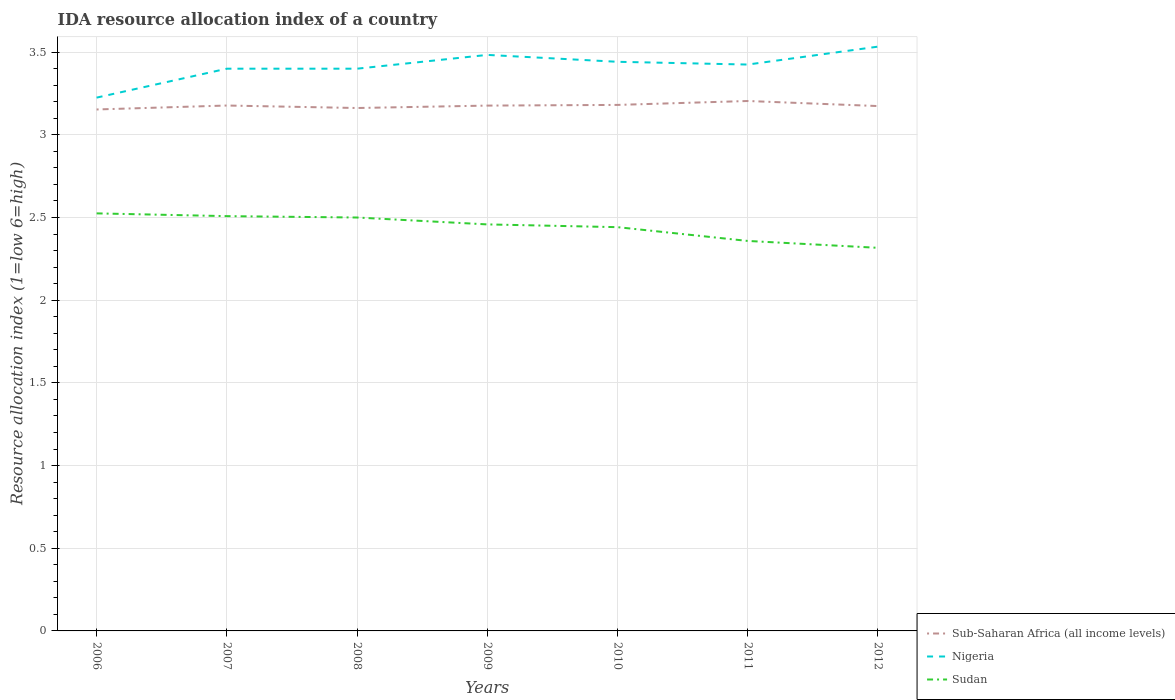Across all years, what is the maximum IDA resource allocation index in Nigeria?
Provide a succinct answer. 3.23. What is the total IDA resource allocation index in Nigeria in the graph?
Ensure brevity in your answer.  -0.09. What is the difference between the highest and the second highest IDA resource allocation index in Sub-Saharan Africa (all income levels)?
Give a very brief answer. 0.05. Is the IDA resource allocation index in Nigeria strictly greater than the IDA resource allocation index in Sudan over the years?
Your answer should be very brief. No. How many years are there in the graph?
Give a very brief answer. 7. Are the values on the major ticks of Y-axis written in scientific E-notation?
Ensure brevity in your answer.  No. Does the graph contain grids?
Make the answer very short. Yes. How many legend labels are there?
Make the answer very short. 3. How are the legend labels stacked?
Offer a terse response. Vertical. What is the title of the graph?
Your response must be concise. IDA resource allocation index of a country. Does "Sub-Saharan Africa (developing only)" appear as one of the legend labels in the graph?
Provide a short and direct response. No. What is the label or title of the Y-axis?
Keep it short and to the point. Resource allocation index (1=low 6=high). What is the Resource allocation index (1=low 6=high) in Sub-Saharan Africa (all income levels) in 2006?
Your answer should be very brief. 3.15. What is the Resource allocation index (1=low 6=high) in Nigeria in 2006?
Keep it short and to the point. 3.23. What is the Resource allocation index (1=low 6=high) of Sudan in 2006?
Give a very brief answer. 2.52. What is the Resource allocation index (1=low 6=high) of Sub-Saharan Africa (all income levels) in 2007?
Ensure brevity in your answer.  3.18. What is the Resource allocation index (1=low 6=high) of Sudan in 2007?
Offer a terse response. 2.51. What is the Resource allocation index (1=low 6=high) of Sub-Saharan Africa (all income levels) in 2008?
Make the answer very short. 3.16. What is the Resource allocation index (1=low 6=high) in Sub-Saharan Africa (all income levels) in 2009?
Your answer should be very brief. 3.18. What is the Resource allocation index (1=low 6=high) of Nigeria in 2009?
Provide a short and direct response. 3.48. What is the Resource allocation index (1=low 6=high) in Sudan in 2009?
Ensure brevity in your answer.  2.46. What is the Resource allocation index (1=low 6=high) in Sub-Saharan Africa (all income levels) in 2010?
Your answer should be very brief. 3.18. What is the Resource allocation index (1=low 6=high) in Nigeria in 2010?
Give a very brief answer. 3.44. What is the Resource allocation index (1=low 6=high) in Sudan in 2010?
Offer a terse response. 2.44. What is the Resource allocation index (1=low 6=high) of Sub-Saharan Africa (all income levels) in 2011?
Give a very brief answer. 3.2. What is the Resource allocation index (1=low 6=high) of Nigeria in 2011?
Provide a succinct answer. 3.42. What is the Resource allocation index (1=low 6=high) of Sudan in 2011?
Offer a very short reply. 2.36. What is the Resource allocation index (1=low 6=high) of Sub-Saharan Africa (all income levels) in 2012?
Offer a terse response. 3.17. What is the Resource allocation index (1=low 6=high) in Nigeria in 2012?
Make the answer very short. 3.53. What is the Resource allocation index (1=low 6=high) of Sudan in 2012?
Your response must be concise. 2.32. Across all years, what is the maximum Resource allocation index (1=low 6=high) of Sub-Saharan Africa (all income levels)?
Give a very brief answer. 3.2. Across all years, what is the maximum Resource allocation index (1=low 6=high) in Nigeria?
Give a very brief answer. 3.53. Across all years, what is the maximum Resource allocation index (1=low 6=high) in Sudan?
Keep it short and to the point. 2.52. Across all years, what is the minimum Resource allocation index (1=low 6=high) in Sub-Saharan Africa (all income levels)?
Give a very brief answer. 3.15. Across all years, what is the minimum Resource allocation index (1=low 6=high) of Nigeria?
Give a very brief answer. 3.23. Across all years, what is the minimum Resource allocation index (1=low 6=high) of Sudan?
Your answer should be very brief. 2.32. What is the total Resource allocation index (1=low 6=high) of Sub-Saharan Africa (all income levels) in the graph?
Your response must be concise. 22.23. What is the total Resource allocation index (1=low 6=high) in Nigeria in the graph?
Provide a succinct answer. 23.91. What is the total Resource allocation index (1=low 6=high) of Sudan in the graph?
Your answer should be very brief. 17.11. What is the difference between the Resource allocation index (1=low 6=high) in Sub-Saharan Africa (all income levels) in 2006 and that in 2007?
Provide a succinct answer. -0.02. What is the difference between the Resource allocation index (1=low 6=high) of Nigeria in 2006 and that in 2007?
Provide a succinct answer. -0.17. What is the difference between the Resource allocation index (1=low 6=high) in Sudan in 2006 and that in 2007?
Your answer should be compact. 0.02. What is the difference between the Resource allocation index (1=low 6=high) of Sub-Saharan Africa (all income levels) in 2006 and that in 2008?
Your answer should be compact. -0.01. What is the difference between the Resource allocation index (1=low 6=high) of Nigeria in 2006 and that in 2008?
Keep it short and to the point. -0.17. What is the difference between the Resource allocation index (1=low 6=high) of Sudan in 2006 and that in 2008?
Give a very brief answer. 0.03. What is the difference between the Resource allocation index (1=low 6=high) of Sub-Saharan Africa (all income levels) in 2006 and that in 2009?
Provide a succinct answer. -0.02. What is the difference between the Resource allocation index (1=low 6=high) of Nigeria in 2006 and that in 2009?
Make the answer very short. -0.26. What is the difference between the Resource allocation index (1=low 6=high) in Sudan in 2006 and that in 2009?
Your response must be concise. 0.07. What is the difference between the Resource allocation index (1=low 6=high) of Sub-Saharan Africa (all income levels) in 2006 and that in 2010?
Provide a short and direct response. -0.03. What is the difference between the Resource allocation index (1=low 6=high) in Nigeria in 2006 and that in 2010?
Offer a very short reply. -0.22. What is the difference between the Resource allocation index (1=low 6=high) of Sudan in 2006 and that in 2010?
Offer a very short reply. 0.08. What is the difference between the Resource allocation index (1=low 6=high) of Sub-Saharan Africa (all income levels) in 2006 and that in 2011?
Make the answer very short. -0.05. What is the difference between the Resource allocation index (1=low 6=high) in Nigeria in 2006 and that in 2011?
Your answer should be very brief. -0.2. What is the difference between the Resource allocation index (1=low 6=high) in Sudan in 2006 and that in 2011?
Your response must be concise. 0.17. What is the difference between the Resource allocation index (1=low 6=high) of Sub-Saharan Africa (all income levels) in 2006 and that in 2012?
Ensure brevity in your answer.  -0.02. What is the difference between the Resource allocation index (1=low 6=high) of Nigeria in 2006 and that in 2012?
Provide a succinct answer. -0.31. What is the difference between the Resource allocation index (1=low 6=high) in Sudan in 2006 and that in 2012?
Ensure brevity in your answer.  0.21. What is the difference between the Resource allocation index (1=low 6=high) of Sub-Saharan Africa (all income levels) in 2007 and that in 2008?
Provide a succinct answer. 0.02. What is the difference between the Resource allocation index (1=low 6=high) of Nigeria in 2007 and that in 2008?
Offer a very short reply. 0. What is the difference between the Resource allocation index (1=low 6=high) in Sudan in 2007 and that in 2008?
Keep it short and to the point. 0.01. What is the difference between the Resource allocation index (1=low 6=high) of Nigeria in 2007 and that in 2009?
Provide a short and direct response. -0.08. What is the difference between the Resource allocation index (1=low 6=high) in Sub-Saharan Africa (all income levels) in 2007 and that in 2010?
Offer a very short reply. -0. What is the difference between the Resource allocation index (1=low 6=high) in Nigeria in 2007 and that in 2010?
Your answer should be compact. -0.04. What is the difference between the Resource allocation index (1=low 6=high) of Sudan in 2007 and that in 2010?
Offer a very short reply. 0.07. What is the difference between the Resource allocation index (1=low 6=high) in Sub-Saharan Africa (all income levels) in 2007 and that in 2011?
Your answer should be very brief. -0.03. What is the difference between the Resource allocation index (1=low 6=high) in Nigeria in 2007 and that in 2011?
Your answer should be very brief. -0.03. What is the difference between the Resource allocation index (1=low 6=high) of Sub-Saharan Africa (all income levels) in 2007 and that in 2012?
Your response must be concise. 0. What is the difference between the Resource allocation index (1=low 6=high) in Nigeria in 2007 and that in 2012?
Offer a very short reply. -0.13. What is the difference between the Resource allocation index (1=low 6=high) in Sudan in 2007 and that in 2012?
Provide a succinct answer. 0.19. What is the difference between the Resource allocation index (1=low 6=high) in Sub-Saharan Africa (all income levels) in 2008 and that in 2009?
Offer a very short reply. -0.01. What is the difference between the Resource allocation index (1=low 6=high) in Nigeria in 2008 and that in 2009?
Offer a very short reply. -0.08. What is the difference between the Resource allocation index (1=low 6=high) in Sudan in 2008 and that in 2009?
Offer a terse response. 0.04. What is the difference between the Resource allocation index (1=low 6=high) in Sub-Saharan Africa (all income levels) in 2008 and that in 2010?
Your response must be concise. -0.02. What is the difference between the Resource allocation index (1=low 6=high) in Nigeria in 2008 and that in 2010?
Your answer should be very brief. -0.04. What is the difference between the Resource allocation index (1=low 6=high) in Sudan in 2008 and that in 2010?
Offer a very short reply. 0.06. What is the difference between the Resource allocation index (1=low 6=high) of Sub-Saharan Africa (all income levels) in 2008 and that in 2011?
Keep it short and to the point. -0.04. What is the difference between the Resource allocation index (1=low 6=high) of Nigeria in 2008 and that in 2011?
Your response must be concise. -0.03. What is the difference between the Resource allocation index (1=low 6=high) in Sudan in 2008 and that in 2011?
Make the answer very short. 0.14. What is the difference between the Resource allocation index (1=low 6=high) in Sub-Saharan Africa (all income levels) in 2008 and that in 2012?
Your answer should be compact. -0.01. What is the difference between the Resource allocation index (1=low 6=high) in Nigeria in 2008 and that in 2012?
Your response must be concise. -0.13. What is the difference between the Resource allocation index (1=low 6=high) in Sudan in 2008 and that in 2012?
Your answer should be compact. 0.18. What is the difference between the Resource allocation index (1=low 6=high) of Sub-Saharan Africa (all income levels) in 2009 and that in 2010?
Provide a short and direct response. -0. What is the difference between the Resource allocation index (1=low 6=high) in Nigeria in 2009 and that in 2010?
Offer a terse response. 0.04. What is the difference between the Resource allocation index (1=low 6=high) of Sudan in 2009 and that in 2010?
Make the answer very short. 0.02. What is the difference between the Resource allocation index (1=low 6=high) of Sub-Saharan Africa (all income levels) in 2009 and that in 2011?
Provide a short and direct response. -0.03. What is the difference between the Resource allocation index (1=low 6=high) of Nigeria in 2009 and that in 2011?
Your answer should be compact. 0.06. What is the difference between the Resource allocation index (1=low 6=high) of Sub-Saharan Africa (all income levels) in 2009 and that in 2012?
Ensure brevity in your answer.  0. What is the difference between the Resource allocation index (1=low 6=high) of Sudan in 2009 and that in 2012?
Provide a short and direct response. 0.14. What is the difference between the Resource allocation index (1=low 6=high) of Sub-Saharan Africa (all income levels) in 2010 and that in 2011?
Give a very brief answer. -0.02. What is the difference between the Resource allocation index (1=low 6=high) in Nigeria in 2010 and that in 2011?
Offer a very short reply. 0.02. What is the difference between the Resource allocation index (1=low 6=high) of Sudan in 2010 and that in 2011?
Offer a terse response. 0.08. What is the difference between the Resource allocation index (1=low 6=high) of Sub-Saharan Africa (all income levels) in 2010 and that in 2012?
Provide a succinct answer. 0.01. What is the difference between the Resource allocation index (1=low 6=high) in Nigeria in 2010 and that in 2012?
Offer a terse response. -0.09. What is the difference between the Resource allocation index (1=low 6=high) of Sub-Saharan Africa (all income levels) in 2011 and that in 2012?
Keep it short and to the point. 0.03. What is the difference between the Resource allocation index (1=low 6=high) of Nigeria in 2011 and that in 2012?
Offer a terse response. -0.11. What is the difference between the Resource allocation index (1=low 6=high) in Sudan in 2011 and that in 2012?
Your answer should be compact. 0.04. What is the difference between the Resource allocation index (1=low 6=high) in Sub-Saharan Africa (all income levels) in 2006 and the Resource allocation index (1=low 6=high) in Nigeria in 2007?
Provide a succinct answer. -0.25. What is the difference between the Resource allocation index (1=low 6=high) of Sub-Saharan Africa (all income levels) in 2006 and the Resource allocation index (1=low 6=high) of Sudan in 2007?
Your answer should be very brief. 0.65. What is the difference between the Resource allocation index (1=low 6=high) in Nigeria in 2006 and the Resource allocation index (1=low 6=high) in Sudan in 2007?
Provide a succinct answer. 0.72. What is the difference between the Resource allocation index (1=low 6=high) of Sub-Saharan Africa (all income levels) in 2006 and the Resource allocation index (1=low 6=high) of Nigeria in 2008?
Provide a short and direct response. -0.25. What is the difference between the Resource allocation index (1=low 6=high) of Sub-Saharan Africa (all income levels) in 2006 and the Resource allocation index (1=low 6=high) of Sudan in 2008?
Offer a very short reply. 0.65. What is the difference between the Resource allocation index (1=low 6=high) in Nigeria in 2006 and the Resource allocation index (1=low 6=high) in Sudan in 2008?
Your answer should be very brief. 0.72. What is the difference between the Resource allocation index (1=low 6=high) in Sub-Saharan Africa (all income levels) in 2006 and the Resource allocation index (1=low 6=high) in Nigeria in 2009?
Your answer should be compact. -0.33. What is the difference between the Resource allocation index (1=low 6=high) in Sub-Saharan Africa (all income levels) in 2006 and the Resource allocation index (1=low 6=high) in Sudan in 2009?
Your answer should be compact. 0.69. What is the difference between the Resource allocation index (1=low 6=high) of Nigeria in 2006 and the Resource allocation index (1=low 6=high) of Sudan in 2009?
Ensure brevity in your answer.  0.77. What is the difference between the Resource allocation index (1=low 6=high) of Sub-Saharan Africa (all income levels) in 2006 and the Resource allocation index (1=low 6=high) of Nigeria in 2010?
Offer a very short reply. -0.29. What is the difference between the Resource allocation index (1=low 6=high) of Sub-Saharan Africa (all income levels) in 2006 and the Resource allocation index (1=low 6=high) of Sudan in 2010?
Ensure brevity in your answer.  0.71. What is the difference between the Resource allocation index (1=low 6=high) in Nigeria in 2006 and the Resource allocation index (1=low 6=high) in Sudan in 2010?
Make the answer very short. 0.78. What is the difference between the Resource allocation index (1=low 6=high) in Sub-Saharan Africa (all income levels) in 2006 and the Resource allocation index (1=low 6=high) in Nigeria in 2011?
Ensure brevity in your answer.  -0.27. What is the difference between the Resource allocation index (1=low 6=high) in Sub-Saharan Africa (all income levels) in 2006 and the Resource allocation index (1=low 6=high) in Sudan in 2011?
Make the answer very short. 0.8. What is the difference between the Resource allocation index (1=low 6=high) in Nigeria in 2006 and the Resource allocation index (1=low 6=high) in Sudan in 2011?
Offer a very short reply. 0.87. What is the difference between the Resource allocation index (1=low 6=high) in Sub-Saharan Africa (all income levels) in 2006 and the Resource allocation index (1=low 6=high) in Nigeria in 2012?
Ensure brevity in your answer.  -0.38. What is the difference between the Resource allocation index (1=low 6=high) of Sub-Saharan Africa (all income levels) in 2006 and the Resource allocation index (1=low 6=high) of Sudan in 2012?
Provide a succinct answer. 0.84. What is the difference between the Resource allocation index (1=low 6=high) in Nigeria in 2006 and the Resource allocation index (1=low 6=high) in Sudan in 2012?
Ensure brevity in your answer.  0.91. What is the difference between the Resource allocation index (1=low 6=high) of Sub-Saharan Africa (all income levels) in 2007 and the Resource allocation index (1=low 6=high) of Nigeria in 2008?
Provide a short and direct response. -0.22. What is the difference between the Resource allocation index (1=low 6=high) in Sub-Saharan Africa (all income levels) in 2007 and the Resource allocation index (1=low 6=high) in Sudan in 2008?
Make the answer very short. 0.68. What is the difference between the Resource allocation index (1=low 6=high) in Sub-Saharan Africa (all income levels) in 2007 and the Resource allocation index (1=low 6=high) in Nigeria in 2009?
Make the answer very short. -0.31. What is the difference between the Resource allocation index (1=low 6=high) in Sub-Saharan Africa (all income levels) in 2007 and the Resource allocation index (1=low 6=high) in Sudan in 2009?
Provide a succinct answer. 0.72. What is the difference between the Resource allocation index (1=low 6=high) of Nigeria in 2007 and the Resource allocation index (1=low 6=high) of Sudan in 2009?
Your answer should be very brief. 0.94. What is the difference between the Resource allocation index (1=low 6=high) in Sub-Saharan Africa (all income levels) in 2007 and the Resource allocation index (1=low 6=high) in Nigeria in 2010?
Keep it short and to the point. -0.26. What is the difference between the Resource allocation index (1=low 6=high) of Sub-Saharan Africa (all income levels) in 2007 and the Resource allocation index (1=low 6=high) of Sudan in 2010?
Your response must be concise. 0.74. What is the difference between the Resource allocation index (1=low 6=high) of Nigeria in 2007 and the Resource allocation index (1=low 6=high) of Sudan in 2010?
Ensure brevity in your answer.  0.96. What is the difference between the Resource allocation index (1=low 6=high) in Sub-Saharan Africa (all income levels) in 2007 and the Resource allocation index (1=low 6=high) in Nigeria in 2011?
Your answer should be very brief. -0.25. What is the difference between the Resource allocation index (1=low 6=high) in Sub-Saharan Africa (all income levels) in 2007 and the Resource allocation index (1=low 6=high) in Sudan in 2011?
Your answer should be very brief. 0.82. What is the difference between the Resource allocation index (1=low 6=high) in Nigeria in 2007 and the Resource allocation index (1=low 6=high) in Sudan in 2011?
Your answer should be very brief. 1.04. What is the difference between the Resource allocation index (1=low 6=high) in Sub-Saharan Africa (all income levels) in 2007 and the Resource allocation index (1=low 6=high) in Nigeria in 2012?
Ensure brevity in your answer.  -0.36. What is the difference between the Resource allocation index (1=low 6=high) in Sub-Saharan Africa (all income levels) in 2007 and the Resource allocation index (1=low 6=high) in Sudan in 2012?
Make the answer very short. 0.86. What is the difference between the Resource allocation index (1=low 6=high) of Sub-Saharan Africa (all income levels) in 2008 and the Resource allocation index (1=low 6=high) of Nigeria in 2009?
Keep it short and to the point. -0.32. What is the difference between the Resource allocation index (1=low 6=high) of Sub-Saharan Africa (all income levels) in 2008 and the Resource allocation index (1=low 6=high) of Sudan in 2009?
Provide a short and direct response. 0.7. What is the difference between the Resource allocation index (1=low 6=high) of Nigeria in 2008 and the Resource allocation index (1=low 6=high) of Sudan in 2009?
Give a very brief answer. 0.94. What is the difference between the Resource allocation index (1=low 6=high) in Sub-Saharan Africa (all income levels) in 2008 and the Resource allocation index (1=low 6=high) in Nigeria in 2010?
Make the answer very short. -0.28. What is the difference between the Resource allocation index (1=low 6=high) of Sub-Saharan Africa (all income levels) in 2008 and the Resource allocation index (1=low 6=high) of Sudan in 2010?
Your answer should be very brief. 0.72. What is the difference between the Resource allocation index (1=low 6=high) in Sub-Saharan Africa (all income levels) in 2008 and the Resource allocation index (1=low 6=high) in Nigeria in 2011?
Keep it short and to the point. -0.26. What is the difference between the Resource allocation index (1=low 6=high) in Sub-Saharan Africa (all income levels) in 2008 and the Resource allocation index (1=low 6=high) in Sudan in 2011?
Ensure brevity in your answer.  0.8. What is the difference between the Resource allocation index (1=low 6=high) in Nigeria in 2008 and the Resource allocation index (1=low 6=high) in Sudan in 2011?
Your answer should be very brief. 1.04. What is the difference between the Resource allocation index (1=low 6=high) of Sub-Saharan Africa (all income levels) in 2008 and the Resource allocation index (1=low 6=high) of Nigeria in 2012?
Make the answer very short. -0.37. What is the difference between the Resource allocation index (1=low 6=high) in Sub-Saharan Africa (all income levels) in 2008 and the Resource allocation index (1=low 6=high) in Sudan in 2012?
Offer a very short reply. 0.85. What is the difference between the Resource allocation index (1=low 6=high) of Nigeria in 2008 and the Resource allocation index (1=low 6=high) of Sudan in 2012?
Offer a very short reply. 1.08. What is the difference between the Resource allocation index (1=low 6=high) of Sub-Saharan Africa (all income levels) in 2009 and the Resource allocation index (1=low 6=high) of Nigeria in 2010?
Ensure brevity in your answer.  -0.26. What is the difference between the Resource allocation index (1=low 6=high) in Sub-Saharan Africa (all income levels) in 2009 and the Resource allocation index (1=low 6=high) in Sudan in 2010?
Make the answer very short. 0.74. What is the difference between the Resource allocation index (1=low 6=high) in Nigeria in 2009 and the Resource allocation index (1=low 6=high) in Sudan in 2010?
Your answer should be compact. 1.04. What is the difference between the Resource allocation index (1=low 6=high) of Sub-Saharan Africa (all income levels) in 2009 and the Resource allocation index (1=low 6=high) of Nigeria in 2011?
Keep it short and to the point. -0.25. What is the difference between the Resource allocation index (1=low 6=high) in Sub-Saharan Africa (all income levels) in 2009 and the Resource allocation index (1=low 6=high) in Sudan in 2011?
Provide a short and direct response. 0.82. What is the difference between the Resource allocation index (1=low 6=high) in Nigeria in 2009 and the Resource allocation index (1=low 6=high) in Sudan in 2011?
Your response must be concise. 1.12. What is the difference between the Resource allocation index (1=low 6=high) of Sub-Saharan Africa (all income levels) in 2009 and the Resource allocation index (1=low 6=high) of Nigeria in 2012?
Offer a very short reply. -0.36. What is the difference between the Resource allocation index (1=low 6=high) of Sub-Saharan Africa (all income levels) in 2009 and the Resource allocation index (1=low 6=high) of Sudan in 2012?
Provide a short and direct response. 0.86. What is the difference between the Resource allocation index (1=low 6=high) in Nigeria in 2009 and the Resource allocation index (1=low 6=high) in Sudan in 2012?
Make the answer very short. 1.17. What is the difference between the Resource allocation index (1=low 6=high) in Sub-Saharan Africa (all income levels) in 2010 and the Resource allocation index (1=low 6=high) in Nigeria in 2011?
Keep it short and to the point. -0.24. What is the difference between the Resource allocation index (1=low 6=high) of Sub-Saharan Africa (all income levels) in 2010 and the Resource allocation index (1=low 6=high) of Sudan in 2011?
Keep it short and to the point. 0.82. What is the difference between the Resource allocation index (1=low 6=high) in Sub-Saharan Africa (all income levels) in 2010 and the Resource allocation index (1=low 6=high) in Nigeria in 2012?
Give a very brief answer. -0.35. What is the difference between the Resource allocation index (1=low 6=high) of Sub-Saharan Africa (all income levels) in 2010 and the Resource allocation index (1=low 6=high) of Sudan in 2012?
Your answer should be compact. 0.86. What is the difference between the Resource allocation index (1=low 6=high) of Nigeria in 2010 and the Resource allocation index (1=low 6=high) of Sudan in 2012?
Offer a very short reply. 1.12. What is the difference between the Resource allocation index (1=low 6=high) of Sub-Saharan Africa (all income levels) in 2011 and the Resource allocation index (1=low 6=high) of Nigeria in 2012?
Keep it short and to the point. -0.33. What is the difference between the Resource allocation index (1=low 6=high) of Sub-Saharan Africa (all income levels) in 2011 and the Resource allocation index (1=low 6=high) of Sudan in 2012?
Offer a very short reply. 0.89. What is the difference between the Resource allocation index (1=low 6=high) in Nigeria in 2011 and the Resource allocation index (1=low 6=high) in Sudan in 2012?
Provide a short and direct response. 1.11. What is the average Resource allocation index (1=low 6=high) of Sub-Saharan Africa (all income levels) per year?
Offer a very short reply. 3.18. What is the average Resource allocation index (1=low 6=high) of Nigeria per year?
Your answer should be compact. 3.42. What is the average Resource allocation index (1=low 6=high) in Sudan per year?
Ensure brevity in your answer.  2.44. In the year 2006, what is the difference between the Resource allocation index (1=low 6=high) in Sub-Saharan Africa (all income levels) and Resource allocation index (1=low 6=high) in Nigeria?
Your answer should be compact. -0.07. In the year 2006, what is the difference between the Resource allocation index (1=low 6=high) in Sub-Saharan Africa (all income levels) and Resource allocation index (1=low 6=high) in Sudan?
Offer a terse response. 0.63. In the year 2006, what is the difference between the Resource allocation index (1=low 6=high) in Nigeria and Resource allocation index (1=low 6=high) in Sudan?
Ensure brevity in your answer.  0.7. In the year 2007, what is the difference between the Resource allocation index (1=low 6=high) in Sub-Saharan Africa (all income levels) and Resource allocation index (1=low 6=high) in Nigeria?
Give a very brief answer. -0.22. In the year 2007, what is the difference between the Resource allocation index (1=low 6=high) of Sub-Saharan Africa (all income levels) and Resource allocation index (1=low 6=high) of Sudan?
Offer a terse response. 0.67. In the year 2007, what is the difference between the Resource allocation index (1=low 6=high) of Nigeria and Resource allocation index (1=low 6=high) of Sudan?
Offer a very short reply. 0.89. In the year 2008, what is the difference between the Resource allocation index (1=low 6=high) of Sub-Saharan Africa (all income levels) and Resource allocation index (1=low 6=high) of Nigeria?
Keep it short and to the point. -0.24. In the year 2008, what is the difference between the Resource allocation index (1=low 6=high) of Sub-Saharan Africa (all income levels) and Resource allocation index (1=low 6=high) of Sudan?
Provide a succinct answer. 0.66. In the year 2009, what is the difference between the Resource allocation index (1=low 6=high) of Sub-Saharan Africa (all income levels) and Resource allocation index (1=low 6=high) of Nigeria?
Your answer should be compact. -0.31. In the year 2009, what is the difference between the Resource allocation index (1=low 6=high) in Sub-Saharan Africa (all income levels) and Resource allocation index (1=low 6=high) in Sudan?
Offer a terse response. 0.72. In the year 2010, what is the difference between the Resource allocation index (1=low 6=high) in Sub-Saharan Africa (all income levels) and Resource allocation index (1=low 6=high) in Nigeria?
Offer a very short reply. -0.26. In the year 2010, what is the difference between the Resource allocation index (1=low 6=high) in Sub-Saharan Africa (all income levels) and Resource allocation index (1=low 6=high) in Sudan?
Your answer should be very brief. 0.74. In the year 2010, what is the difference between the Resource allocation index (1=low 6=high) of Nigeria and Resource allocation index (1=low 6=high) of Sudan?
Keep it short and to the point. 1. In the year 2011, what is the difference between the Resource allocation index (1=low 6=high) of Sub-Saharan Africa (all income levels) and Resource allocation index (1=low 6=high) of Nigeria?
Keep it short and to the point. -0.22. In the year 2011, what is the difference between the Resource allocation index (1=low 6=high) of Sub-Saharan Africa (all income levels) and Resource allocation index (1=low 6=high) of Sudan?
Your answer should be compact. 0.85. In the year 2011, what is the difference between the Resource allocation index (1=low 6=high) in Nigeria and Resource allocation index (1=low 6=high) in Sudan?
Your answer should be very brief. 1.07. In the year 2012, what is the difference between the Resource allocation index (1=low 6=high) in Sub-Saharan Africa (all income levels) and Resource allocation index (1=low 6=high) in Nigeria?
Your response must be concise. -0.36. In the year 2012, what is the difference between the Resource allocation index (1=low 6=high) of Sub-Saharan Africa (all income levels) and Resource allocation index (1=low 6=high) of Sudan?
Provide a short and direct response. 0.86. In the year 2012, what is the difference between the Resource allocation index (1=low 6=high) of Nigeria and Resource allocation index (1=low 6=high) of Sudan?
Offer a terse response. 1.22. What is the ratio of the Resource allocation index (1=low 6=high) of Nigeria in 2006 to that in 2007?
Provide a short and direct response. 0.95. What is the ratio of the Resource allocation index (1=low 6=high) of Sudan in 2006 to that in 2007?
Provide a succinct answer. 1.01. What is the ratio of the Resource allocation index (1=low 6=high) of Sub-Saharan Africa (all income levels) in 2006 to that in 2008?
Ensure brevity in your answer.  1. What is the ratio of the Resource allocation index (1=low 6=high) in Nigeria in 2006 to that in 2008?
Ensure brevity in your answer.  0.95. What is the ratio of the Resource allocation index (1=low 6=high) of Nigeria in 2006 to that in 2009?
Provide a short and direct response. 0.93. What is the ratio of the Resource allocation index (1=low 6=high) of Sudan in 2006 to that in 2009?
Ensure brevity in your answer.  1.03. What is the ratio of the Resource allocation index (1=low 6=high) in Sub-Saharan Africa (all income levels) in 2006 to that in 2010?
Offer a terse response. 0.99. What is the ratio of the Resource allocation index (1=low 6=high) of Nigeria in 2006 to that in 2010?
Offer a terse response. 0.94. What is the ratio of the Resource allocation index (1=low 6=high) of Sudan in 2006 to that in 2010?
Ensure brevity in your answer.  1.03. What is the ratio of the Resource allocation index (1=low 6=high) in Nigeria in 2006 to that in 2011?
Give a very brief answer. 0.94. What is the ratio of the Resource allocation index (1=low 6=high) of Sudan in 2006 to that in 2011?
Your answer should be very brief. 1.07. What is the ratio of the Resource allocation index (1=low 6=high) of Sub-Saharan Africa (all income levels) in 2006 to that in 2012?
Your answer should be compact. 0.99. What is the ratio of the Resource allocation index (1=low 6=high) in Nigeria in 2006 to that in 2012?
Your response must be concise. 0.91. What is the ratio of the Resource allocation index (1=low 6=high) in Sudan in 2006 to that in 2012?
Keep it short and to the point. 1.09. What is the ratio of the Resource allocation index (1=low 6=high) of Nigeria in 2007 to that in 2008?
Offer a terse response. 1. What is the ratio of the Resource allocation index (1=low 6=high) of Sudan in 2007 to that in 2008?
Ensure brevity in your answer.  1. What is the ratio of the Resource allocation index (1=low 6=high) in Nigeria in 2007 to that in 2009?
Provide a succinct answer. 0.98. What is the ratio of the Resource allocation index (1=low 6=high) in Sudan in 2007 to that in 2009?
Provide a succinct answer. 1.02. What is the ratio of the Resource allocation index (1=low 6=high) in Sub-Saharan Africa (all income levels) in 2007 to that in 2010?
Make the answer very short. 1. What is the ratio of the Resource allocation index (1=low 6=high) of Nigeria in 2007 to that in 2010?
Keep it short and to the point. 0.99. What is the ratio of the Resource allocation index (1=low 6=high) of Sudan in 2007 to that in 2010?
Make the answer very short. 1.03. What is the ratio of the Resource allocation index (1=low 6=high) of Nigeria in 2007 to that in 2011?
Give a very brief answer. 0.99. What is the ratio of the Resource allocation index (1=low 6=high) of Sudan in 2007 to that in 2011?
Offer a very short reply. 1.06. What is the ratio of the Resource allocation index (1=low 6=high) of Nigeria in 2007 to that in 2012?
Provide a succinct answer. 0.96. What is the ratio of the Resource allocation index (1=low 6=high) in Sudan in 2007 to that in 2012?
Make the answer very short. 1.08. What is the ratio of the Resource allocation index (1=low 6=high) in Sub-Saharan Africa (all income levels) in 2008 to that in 2009?
Offer a terse response. 1. What is the ratio of the Resource allocation index (1=low 6=high) of Nigeria in 2008 to that in 2009?
Provide a short and direct response. 0.98. What is the ratio of the Resource allocation index (1=low 6=high) in Sudan in 2008 to that in 2009?
Make the answer very short. 1.02. What is the ratio of the Resource allocation index (1=low 6=high) of Sub-Saharan Africa (all income levels) in 2008 to that in 2010?
Your answer should be compact. 0.99. What is the ratio of the Resource allocation index (1=low 6=high) of Nigeria in 2008 to that in 2010?
Provide a succinct answer. 0.99. What is the ratio of the Resource allocation index (1=low 6=high) in Sudan in 2008 to that in 2010?
Make the answer very short. 1.02. What is the ratio of the Resource allocation index (1=low 6=high) of Nigeria in 2008 to that in 2011?
Offer a terse response. 0.99. What is the ratio of the Resource allocation index (1=low 6=high) in Sudan in 2008 to that in 2011?
Your answer should be very brief. 1.06. What is the ratio of the Resource allocation index (1=low 6=high) of Sub-Saharan Africa (all income levels) in 2008 to that in 2012?
Offer a terse response. 1. What is the ratio of the Resource allocation index (1=low 6=high) of Nigeria in 2008 to that in 2012?
Your answer should be very brief. 0.96. What is the ratio of the Resource allocation index (1=low 6=high) in Sudan in 2008 to that in 2012?
Your response must be concise. 1.08. What is the ratio of the Resource allocation index (1=low 6=high) of Sub-Saharan Africa (all income levels) in 2009 to that in 2010?
Make the answer very short. 1. What is the ratio of the Resource allocation index (1=low 6=high) of Nigeria in 2009 to that in 2010?
Give a very brief answer. 1.01. What is the ratio of the Resource allocation index (1=low 6=high) in Sudan in 2009 to that in 2010?
Provide a succinct answer. 1.01. What is the ratio of the Resource allocation index (1=low 6=high) in Sub-Saharan Africa (all income levels) in 2009 to that in 2011?
Your response must be concise. 0.99. What is the ratio of the Resource allocation index (1=low 6=high) of Nigeria in 2009 to that in 2011?
Your answer should be compact. 1.02. What is the ratio of the Resource allocation index (1=low 6=high) of Sudan in 2009 to that in 2011?
Provide a succinct answer. 1.04. What is the ratio of the Resource allocation index (1=low 6=high) of Nigeria in 2009 to that in 2012?
Make the answer very short. 0.99. What is the ratio of the Resource allocation index (1=low 6=high) of Sudan in 2009 to that in 2012?
Your answer should be very brief. 1.06. What is the ratio of the Resource allocation index (1=low 6=high) of Sub-Saharan Africa (all income levels) in 2010 to that in 2011?
Keep it short and to the point. 0.99. What is the ratio of the Resource allocation index (1=low 6=high) of Nigeria in 2010 to that in 2011?
Provide a succinct answer. 1. What is the ratio of the Resource allocation index (1=low 6=high) in Sudan in 2010 to that in 2011?
Provide a succinct answer. 1.04. What is the ratio of the Resource allocation index (1=low 6=high) in Sub-Saharan Africa (all income levels) in 2010 to that in 2012?
Offer a terse response. 1. What is the ratio of the Resource allocation index (1=low 6=high) in Nigeria in 2010 to that in 2012?
Give a very brief answer. 0.97. What is the ratio of the Resource allocation index (1=low 6=high) in Sudan in 2010 to that in 2012?
Give a very brief answer. 1.05. What is the ratio of the Resource allocation index (1=low 6=high) in Sub-Saharan Africa (all income levels) in 2011 to that in 2012?
Keep it short and to the point. 1.01. What is the ratio of the Resource allocation index (1=low 6=high) in Nigeria in 2011 to that in 2012?
Offer a very short reply. 0.97. What is the ratio of the Resource allocation index (1=low 6=high) in Sudan in 2011 to that in 2012?
Your response must be concise. 1.02. What is the difference between the highest and the second highest Resource allocation index (1=low 6=high) in Sub-Saharan Africa (all income levels)?
Your answer should be very brief. 0.02. What is the difference between the highest and the second highest Resource allocation index (1=low 6=high) in Sudan?
Keep it short and to the point. 0.02. What is the difference between the highest and the lowest Resource allocation index (1=low 6=high) in Sub-Saharan Africa (all income levels)?
Your answer should be compact. 0.05. What is the difference between the highest and the lowest Resource allocation index (1=low 6=high) in Nigeria?
Offer a very short reply. 0.31. What is the difference between the highest and the lowest Resource allocation index (1=low 6=high) in Sudan?
Give a very brief answer. 0.21. 